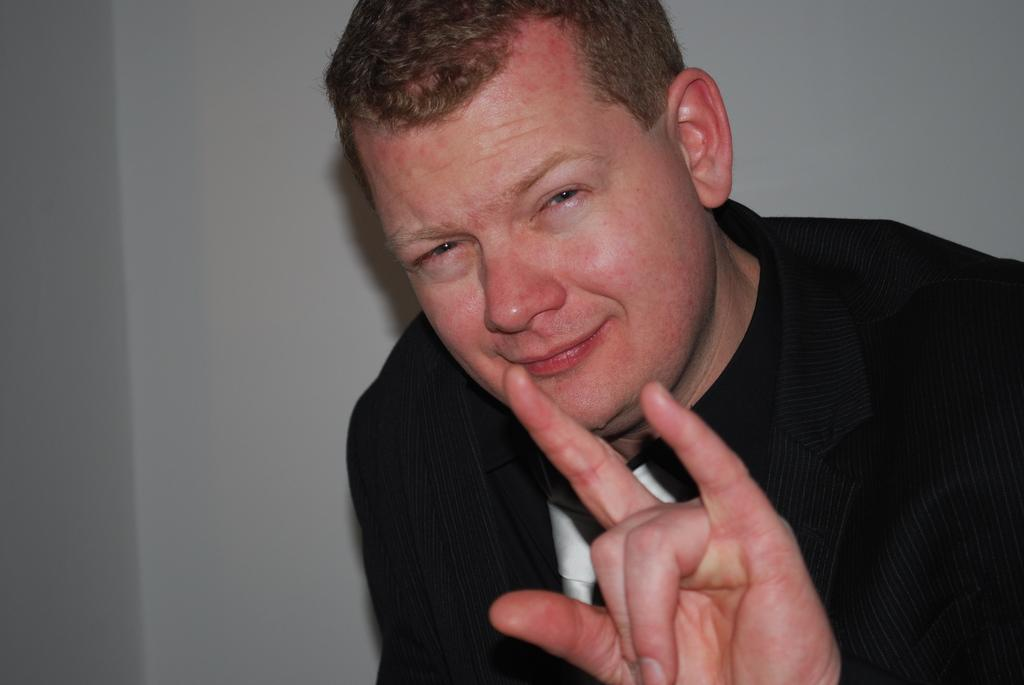Who or what is present in the image? There is a person in the image. What is the person wearing? The person is wearing a black suit. What can be seen in the background of the image? There is a wall in the image. What type of support can be seen in the image? There is no support visible in the image; it only features a person wearing a black suit and a wall in the background. 